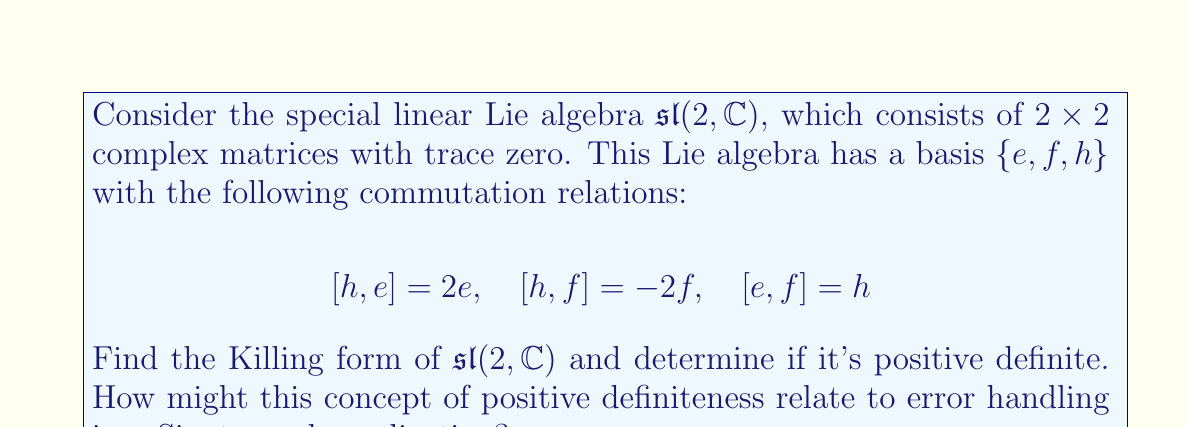Could you help me with this problem? To solve this problem, we'll follow these steps:

1) The Killing form $B(x, y)$ for a Lie algebra is defined as:

   $B(x, y) = \text{tr}(\text{ad}_x \circ \text{ad}_y)$

   where $\text{ad}_x(z) = [x, z]$ and $\text{tr}$ denotes the trace.

2) We need to calculate $\text{ad}_x$ for each basis element:

   For $h$: $\text{ad}_h(e) = 2e$, $\text{ad}_h(f) = -2f$, $\text{ad}_h(h) = 0$
   For $e$: $\text{ad}_e(e) = 0$, $\text{ad}_e(f) = h$, $\text{ad}_e(h) = -2e$
   For $f$: $\text{ad}_f(e) = -h$, $\text{ad}_f(f) = 0$, $\text{ad}_f(h) = 2f$

3) Now we can calculate the Killing form for each pair of basis elements:

   $B(h,h) = \text{tr}(\text{ad}_h \circ \text{ad}_h) = 2^2 + (-2)^2 + 0^2 = 8$
   $B(e,e) = \text{tr}(\text{ad}_e \circ \text{ad}_e) = 0$
   $B(f,f) = \text{tr}(\text{ad}_f \circ \text{ad}_f) = 0$
   $B(h,e) = B(e,h) = \text{tr}(\text{ad}_h \circ \text{ad}_e) = 0$
   $B(h,f) = B(f,h) = \text{tr}(\text{ad}_h \circ \text{ad}_f) = 0$
   $B(e,f) = B(f,e) = \text{tr}(\text{ad}_e \circ \text{ad}_f) = 4$

4) The Killing form can be represented as a matrix:

   $$B = \begin{pmatrix}
   8 & 0 & 0 \\
   0 & 0 & 4 \\
   0 & 4 & 0
   \end{pmatrix}$$

5) To determine if the Killing form is positive definite, we need to check if all its eigenvalues are positive. The characteristic equation is:

   $\det(B - \lambda I) = -\lambda^3 + 8\lambda^2 - 32 = 0$

   The eigenvalues are $\lambda = 8, 2, -2$

6) Since one eigenvalue is negative, the Killing form is not positive definite.

Relating to Sinatra web applications:
In the context of error handling in a Sinatra web application, the concept of positive definiteness could be analogous to ensuring all error states are properly captured and handled. Just as a positive definite form ensures all directions in the space are "positive", robust error handling ensures all potential error states are accounted for and managed effectively. The non-positive definite nature of this Killing form suggests that there might be some "negative" or unhandled cases in our error handling system, which could lead to unexpected behavior or crashes in our Sinatra application.
Answer: The Killing form of $\mathfrak{sl}(2, \mathbb{C})$ is:

$$B = \begin{pmatrix}
8 & 0 & 0 \\
0 & 0 & 4 \\
0 & 4 & 0
\end{pmatrix}$$

It is not positive definite, as it has eigenvalues $8, 2,$ and $-2$. 